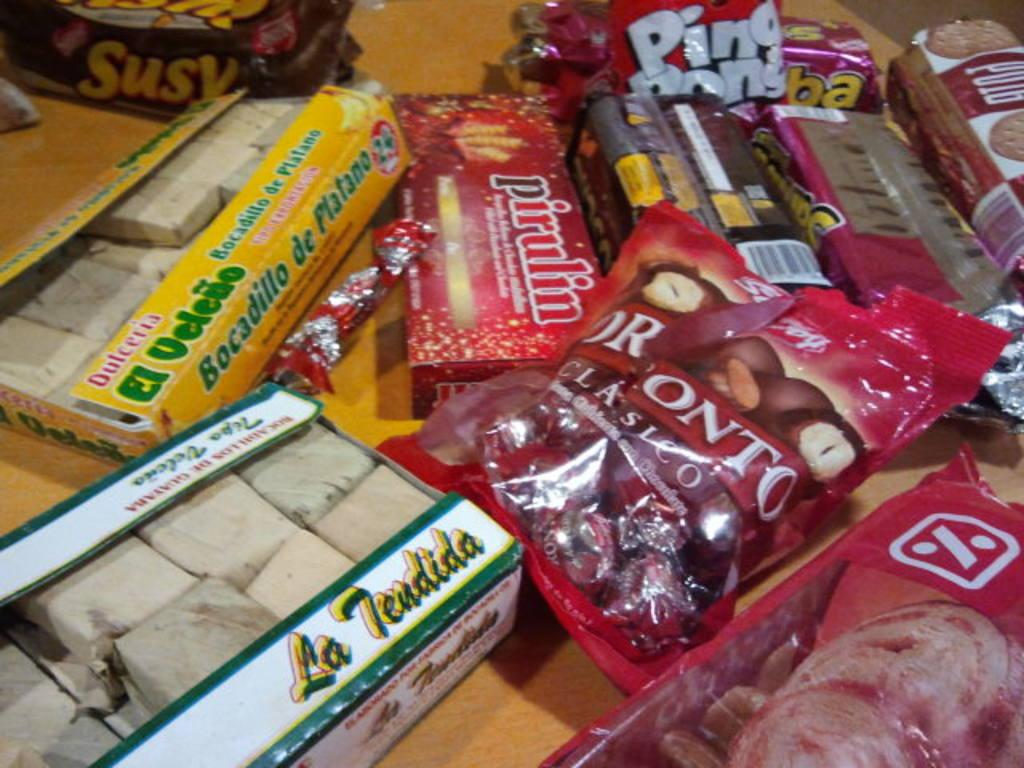What is the main piece of furniture in the image? There is a table in the image. What types of food items are on the table? There are sweets boxes, chocolate packets, and cookies on the table. How many types of food items can be seen on the table? There are at least three types of food items on the table: sweets, chocolate, and cookies. Can you describe the arrangement of the food items on the table? The food items are in the form of packets and boxes, and there are many packets on the table. What type of road can be seen in the image? There is no road present in the image; it features a table with food items. What does the tongue of the person in the image look like? There is no person present in the image, so it is not possible to describe their tongue. 